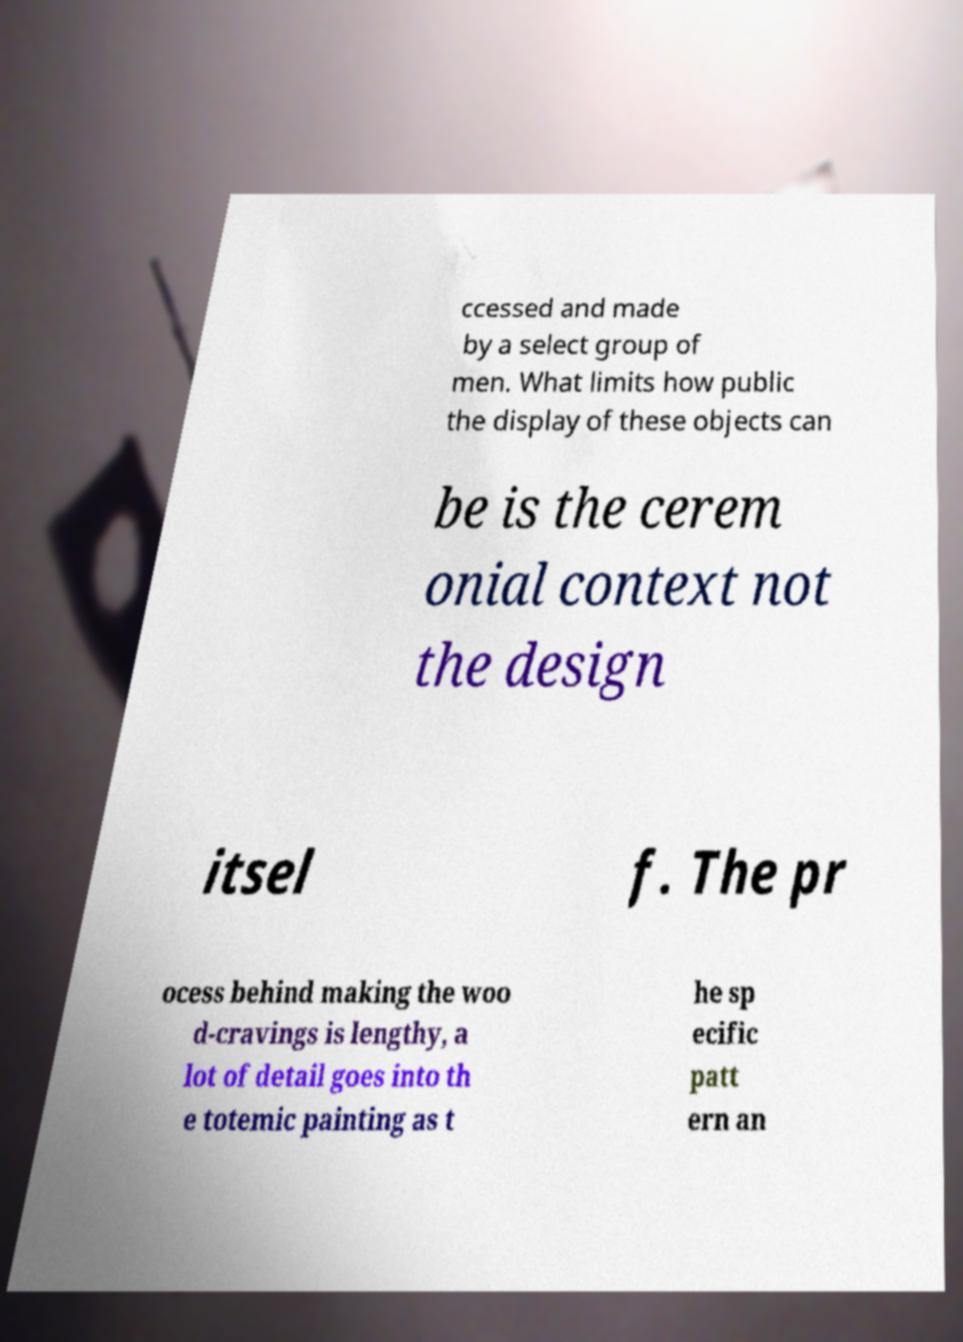What messages or text are displayed in this image? I need them in a readable, typed format. ccessed and made by a select group of men. What limits how public the display of these objects can be is the cerem onial context not the design itsel f. The pr ocess behind making the woo d-cravings is lengthy, a lot of detail goes into th e totemic painting as t he sp ecific patt ern an 